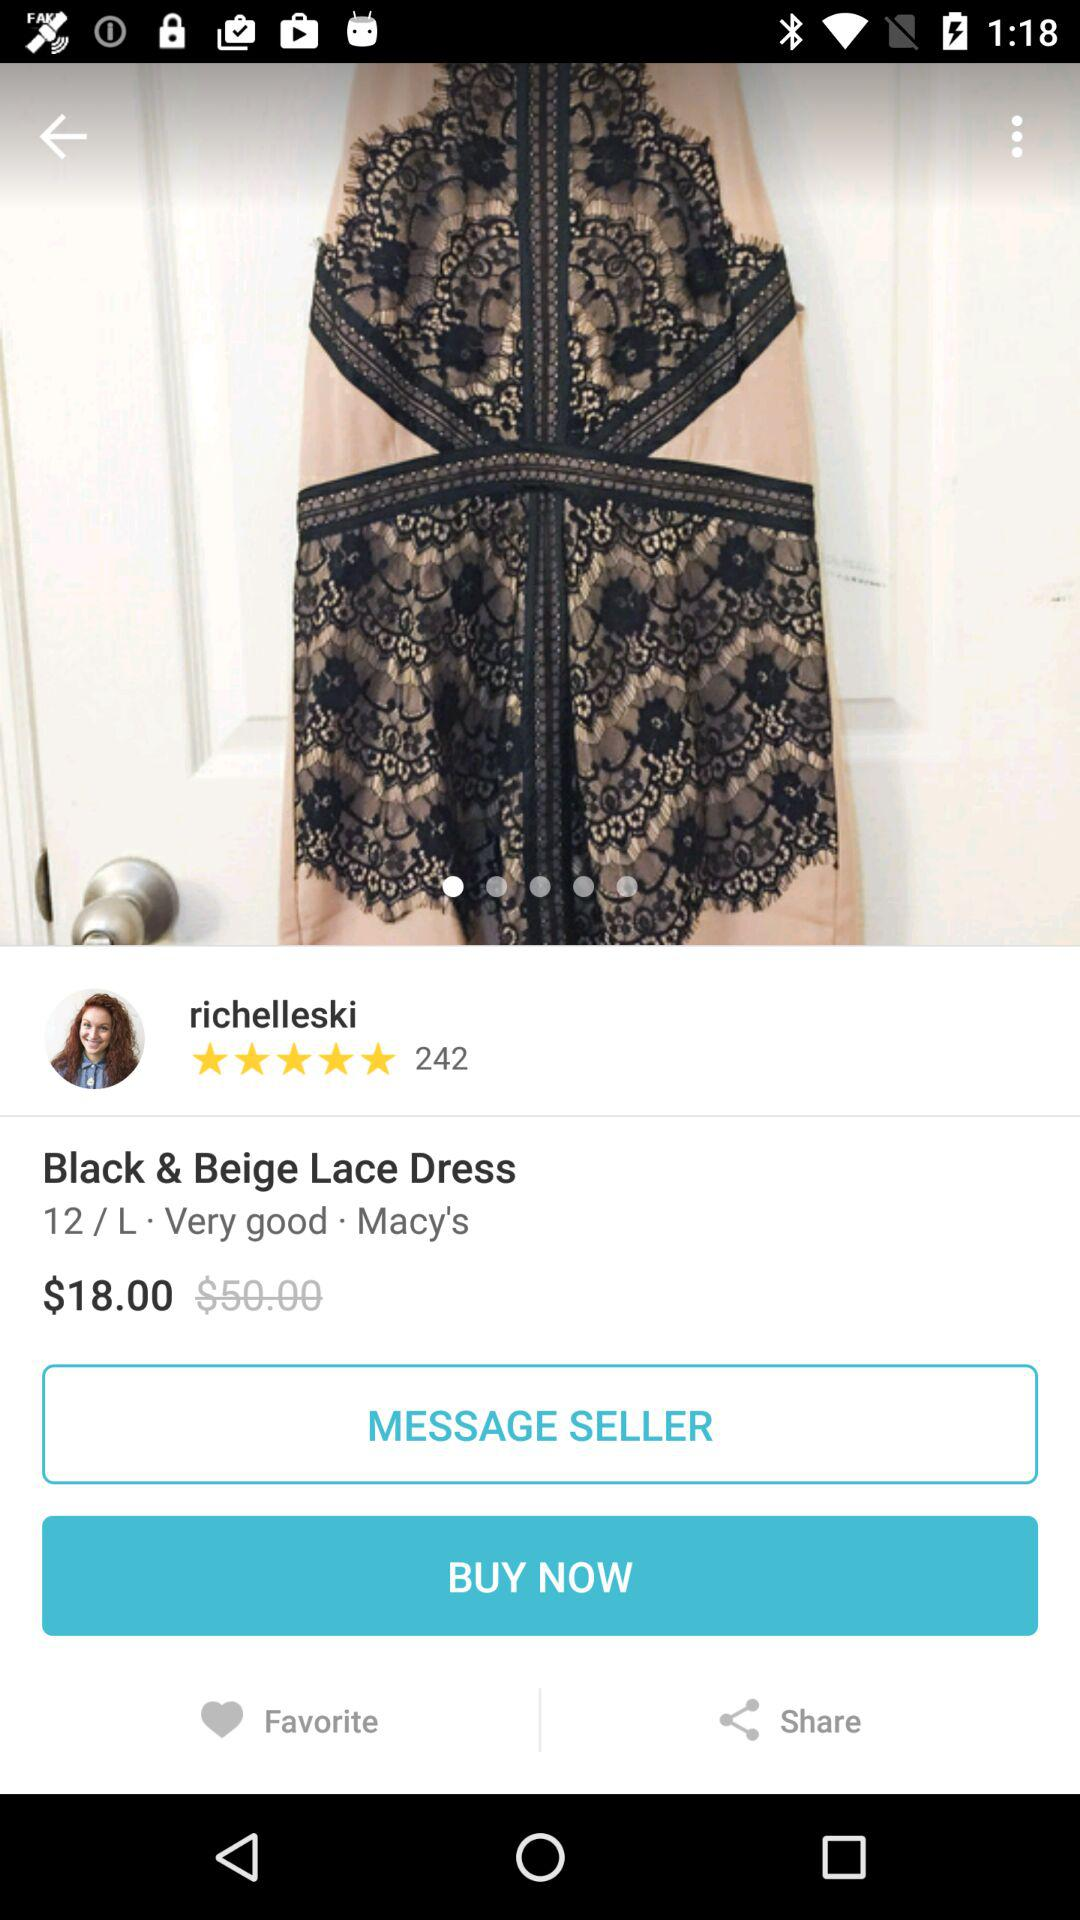What is the size of the dress? The size is "L". 